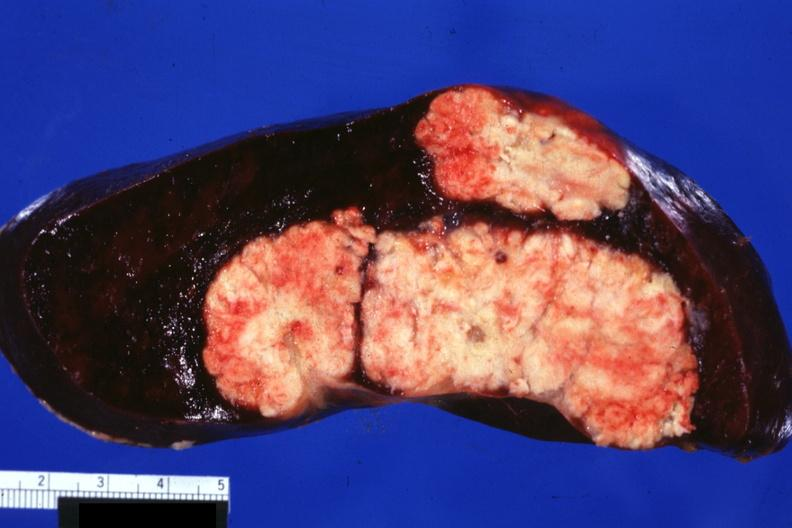s antitrypsin present?
Answer the question using a single word or phrase. No 